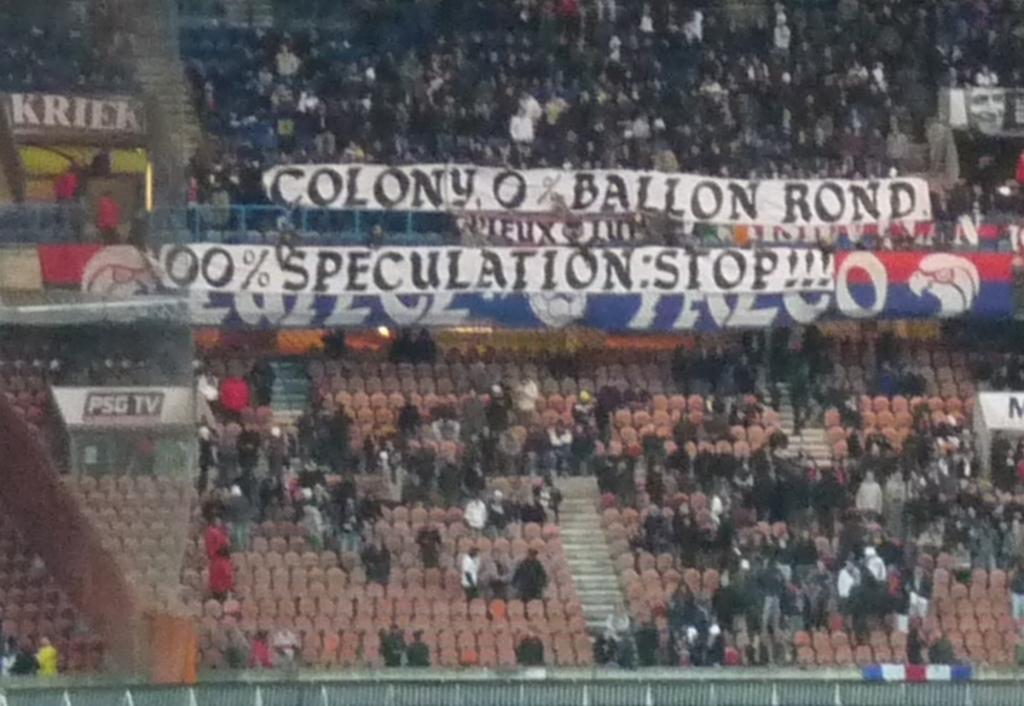<image>
Describe the image concisely. the inside of a stadium with a banner in the crowd that says 'colony 0% ballon rond 100% speculation: STOP!!!' 